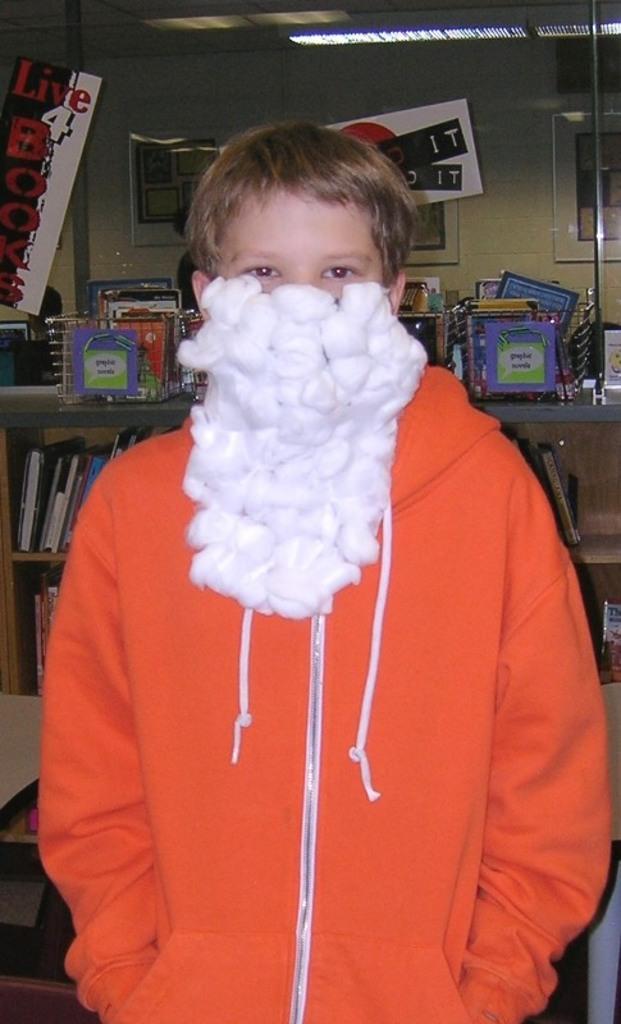Describe this image in one or two sentences. Here I can see a person wearing a jacket and mask to the face. This mask is made up of cotton. In the background there are few books arranged in the rack. At the top of the image there are few frames attached to the wall and also there is a light to the roof. 